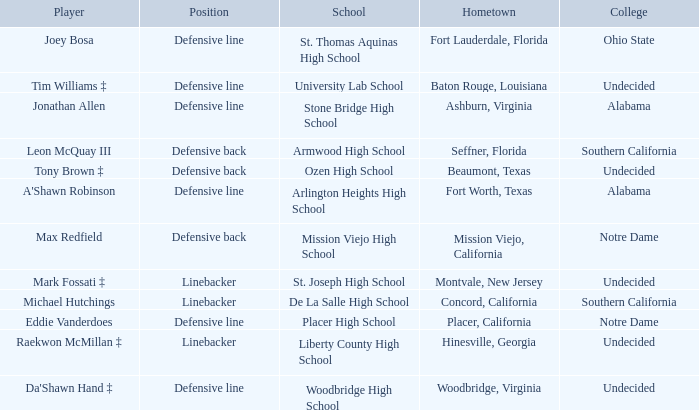What college did the player from Liberty County High School attend? Undecided. 